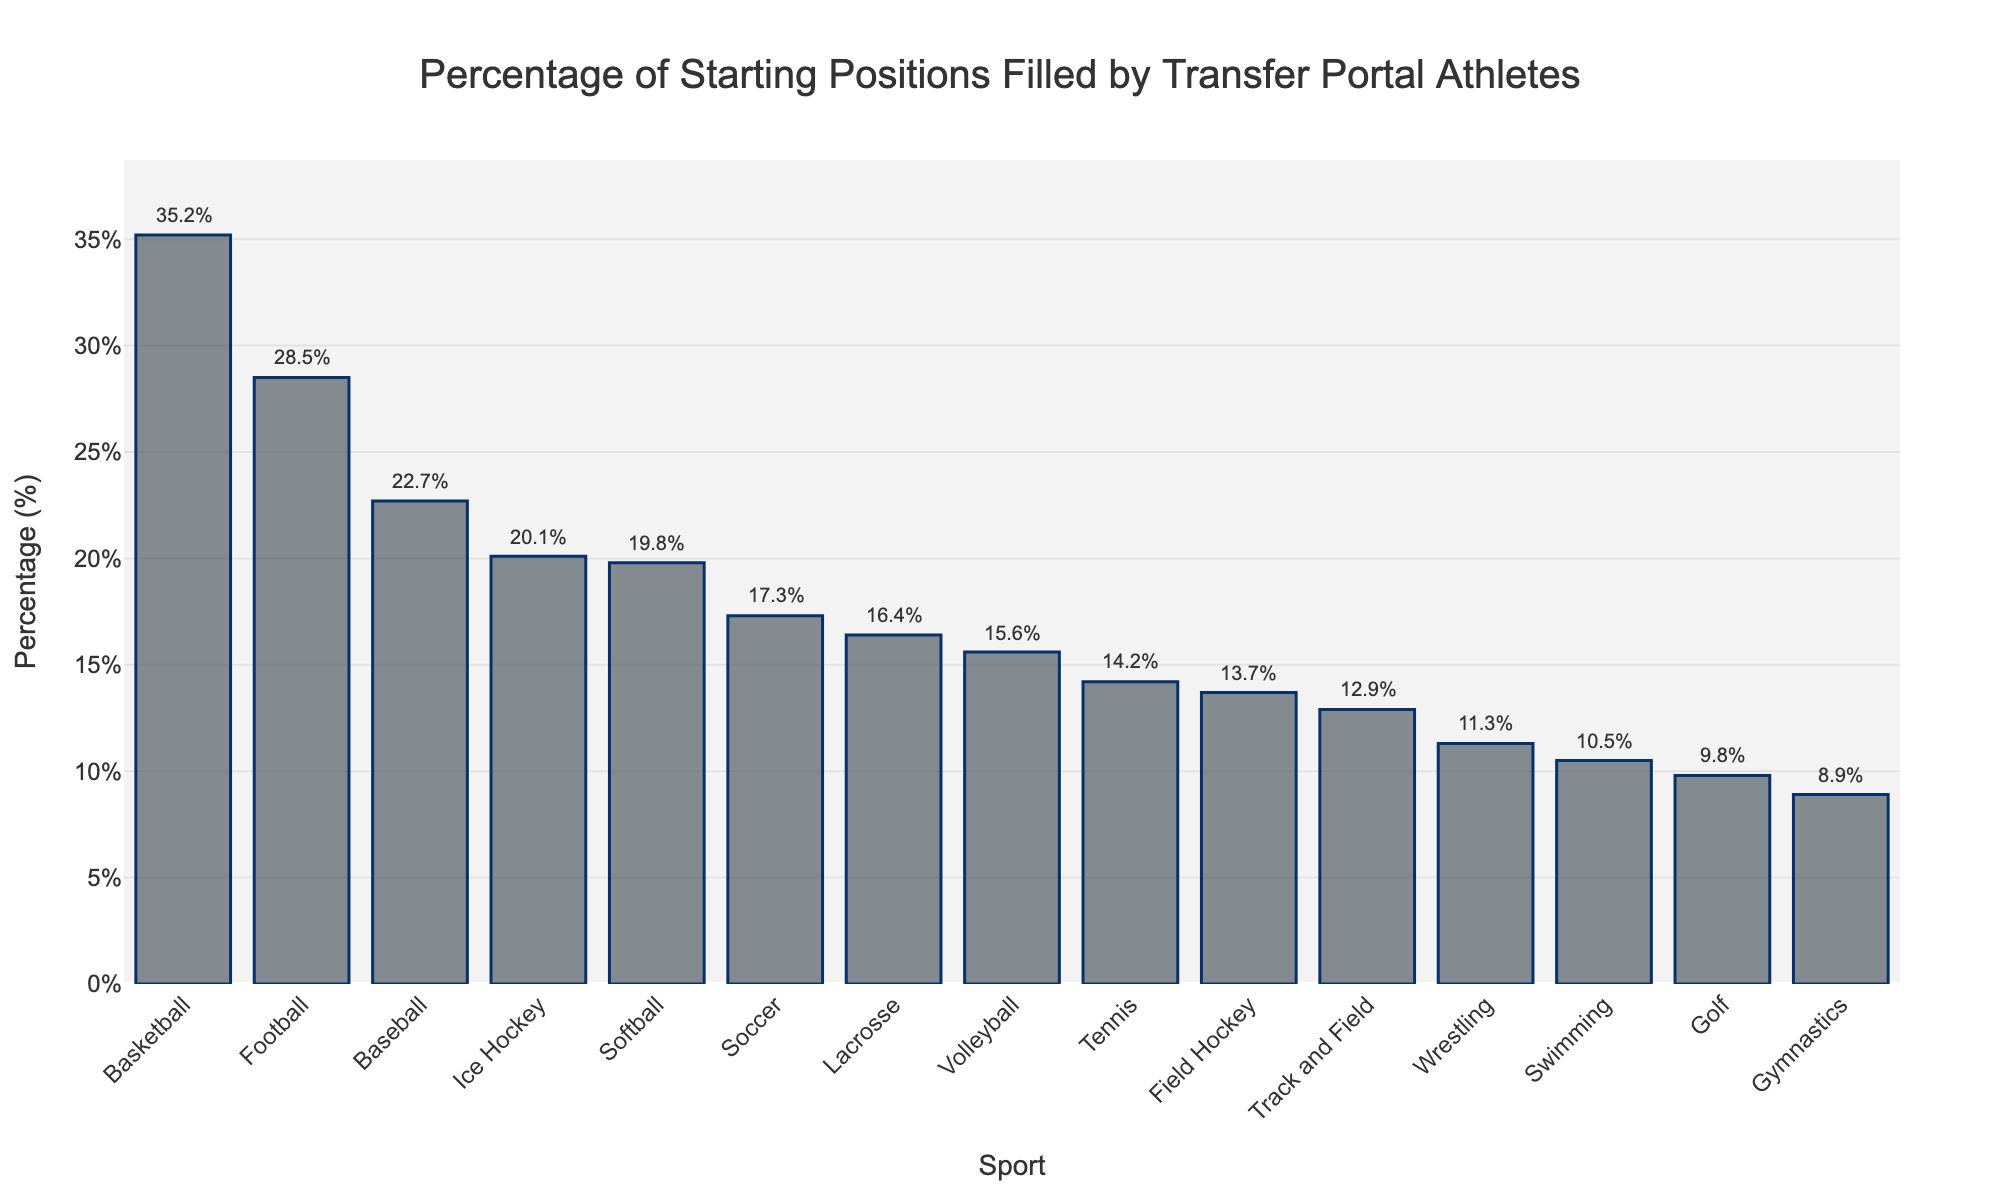What's the sport with the highest percentage of starting positions filled by transfer portal athletes? By looking at the highest bar on the chart, we can see that Basketball has the highest percentage.
Answer: Basketball Which sports have a lower percentage of positions filled by transfer athletes compared to Baseball? Baseball has a percentage of 22.7%. The sports with lower percentages are Softball, Soccer, Volleyball, Track and Field, Swimming, Tennis, Golf, Lacrosse, Field Hockey, Wrestling, and Gymnastics.
Answer: Softball, Soccer, Volleyball, Track and Field, Swimming, Tennis, Golf, Lacrosse, Field Hockey, Wrestling, Gymnastics What's the difference in percentage between Football and Ice Hockey for starting positions filled by transfer athletes? Football has 28.5% and Ice Hockey has 20.1%. So, the difference is 28.5% - 20.1% = 8.4%.
Answer: 8.4% What's the average percentage of starting positions filled by transfer athletes in the sports with more than 20%? The sports with more than 20% are Football (28.5%), Basketball (35.2%), and Baseball (22.7%). The average is (28.5 + 35.2 + 22.7) / 3 = 28.13%.
Answer: 28.13% What is the range of percentages across all sports? The highest percentage is 35.2% in Basketball, and the lowest is 8.9% in Gymnastics. The range is 35.2% - 8.9% = 26.3%.
Answer: 26.3% How many sports have a percentage greater than 20%? By counting the bars that exceed the 20% mark, we have Football, Basketball, Baseball, and Ice Hockey. Thus, there are four sports.
Answer: 4 Which sport has the smallest percentage of starting positions filled by transfer portal athletes? The shortest bar on the chart represents Gymnastics, which has the smallest percentage.
Answer: Gymnastics What is the combined percentage of starting positions filled by transfer athletes in Volleyball and Tennis? Volleyball has 15.6% and Tennis has 14.2%. The combined percentage is 15.6% + 14.2% = 29.8%.
Answer: 29.8% Among the sports Soccer and Volleyball, which has fewer starting positions filled by transfer athletes and by how much? Soccer has 17.3% and Volleyball has 15.6%. Volleyball has fewer by 17.3% - 15.6% = 1.7%.
Answer: Volleyball by 1.7% Which sports fall between 10% and 20% for transfer athlete representation in starting positions? Sports with bars in this range are Softball (19.8%), Soccer (17.3%), Volleyball (15.6%), Track and Field (12.9%), Swimming (10.5%), Tennis (14.2%), Lacrosse (16.4%), and Field Hockey (13.7%).
Answer: Softball, Soccer, Volleyball, Track and Field, Swimming, Tennis, Lacrosse, Field Hockey 